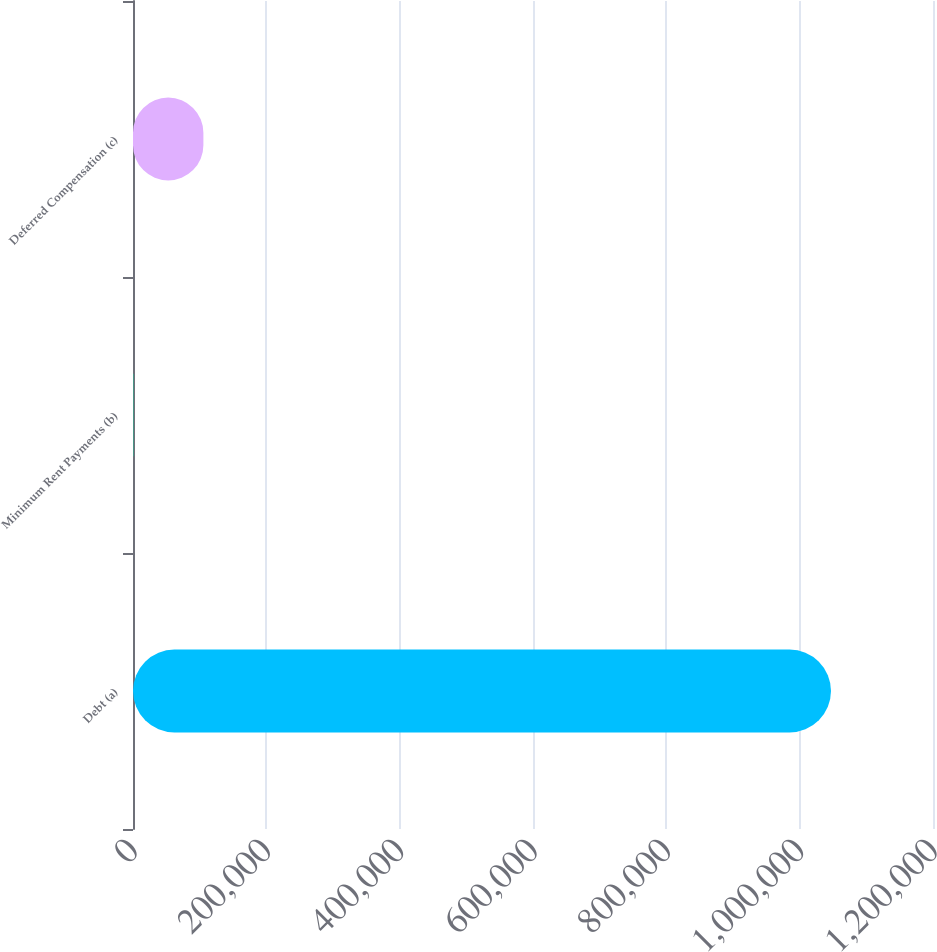Convert chart. <chart><loc_0><loc_0><loc_500><loc_500><bar_chart><fcel>Debt (a)<fcel>Minimum Rent Payments (b)<fcel>Deferred Compensation (c)<nl><fcel>1.04699e+06<fcel>987<fcel>105587<nl></chart> 